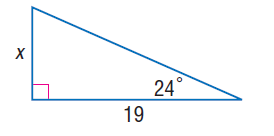Answer the mathemtical geometry problem and directly provide the correct option letter.
Question: Find x.
Choices: A: 1.5 B: 2.0 C: 8.0 D: 8.5 D 